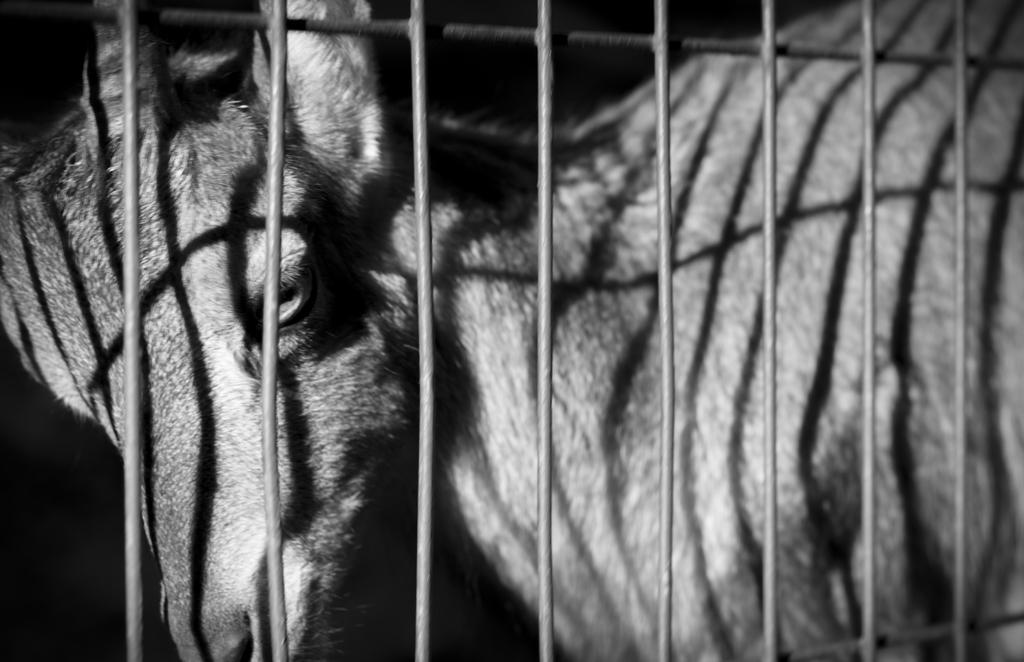Can you describe this image briefly? This image is a black and white image. In this image there is a deer behind the grills. 